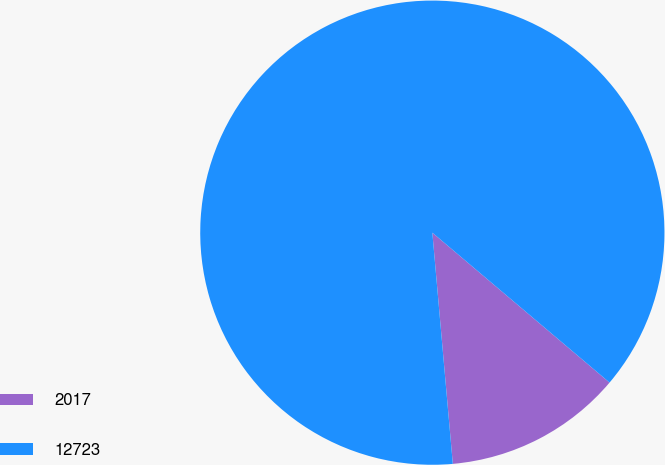Convert chart. <chart><loc_0><loc_0><loc_500><loc_500><pie_chart><fcel>2017<fcel>12723<nl><fcel>12.42%<fcel>87.58%<nl></chart> 